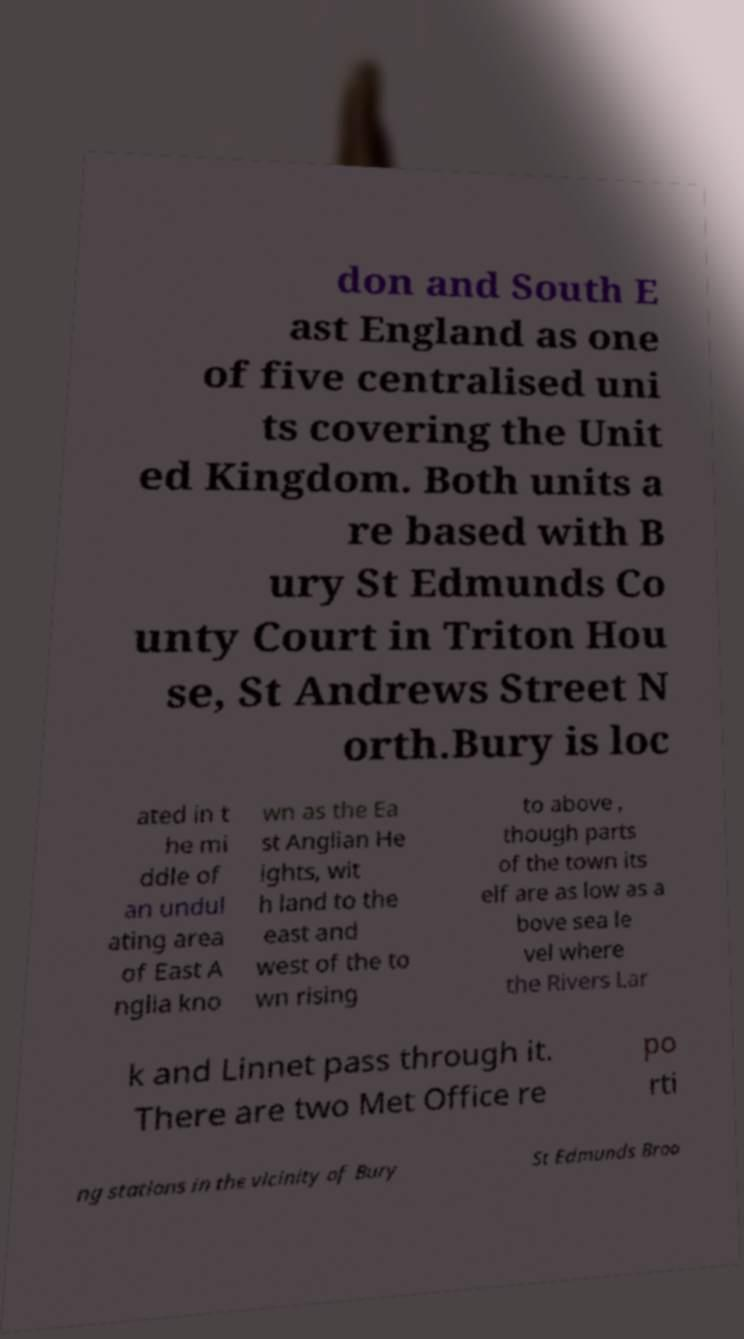Please identify and transcribe the text found in this image. don and South E ast England as one of five centralised uni ts covering the Unit ed Kingdom. Both units a re based with B ury St Edmunds Co unty Court in Triton Hou se, St Andrews Street N orth.Bury is loc ated in t he mi ddle of an undul ating area of East A nglia kno wn as the Ea st Anglian He ights, wit h land to the east and west of the to wn rising to above , though parts of the town its elf are as low as a bove sea le vel where the Rivers Lar k and Linnet pass through it. There are two Met Office re po rti ng stations in the vicinity of Bury St Edmunds Broo 